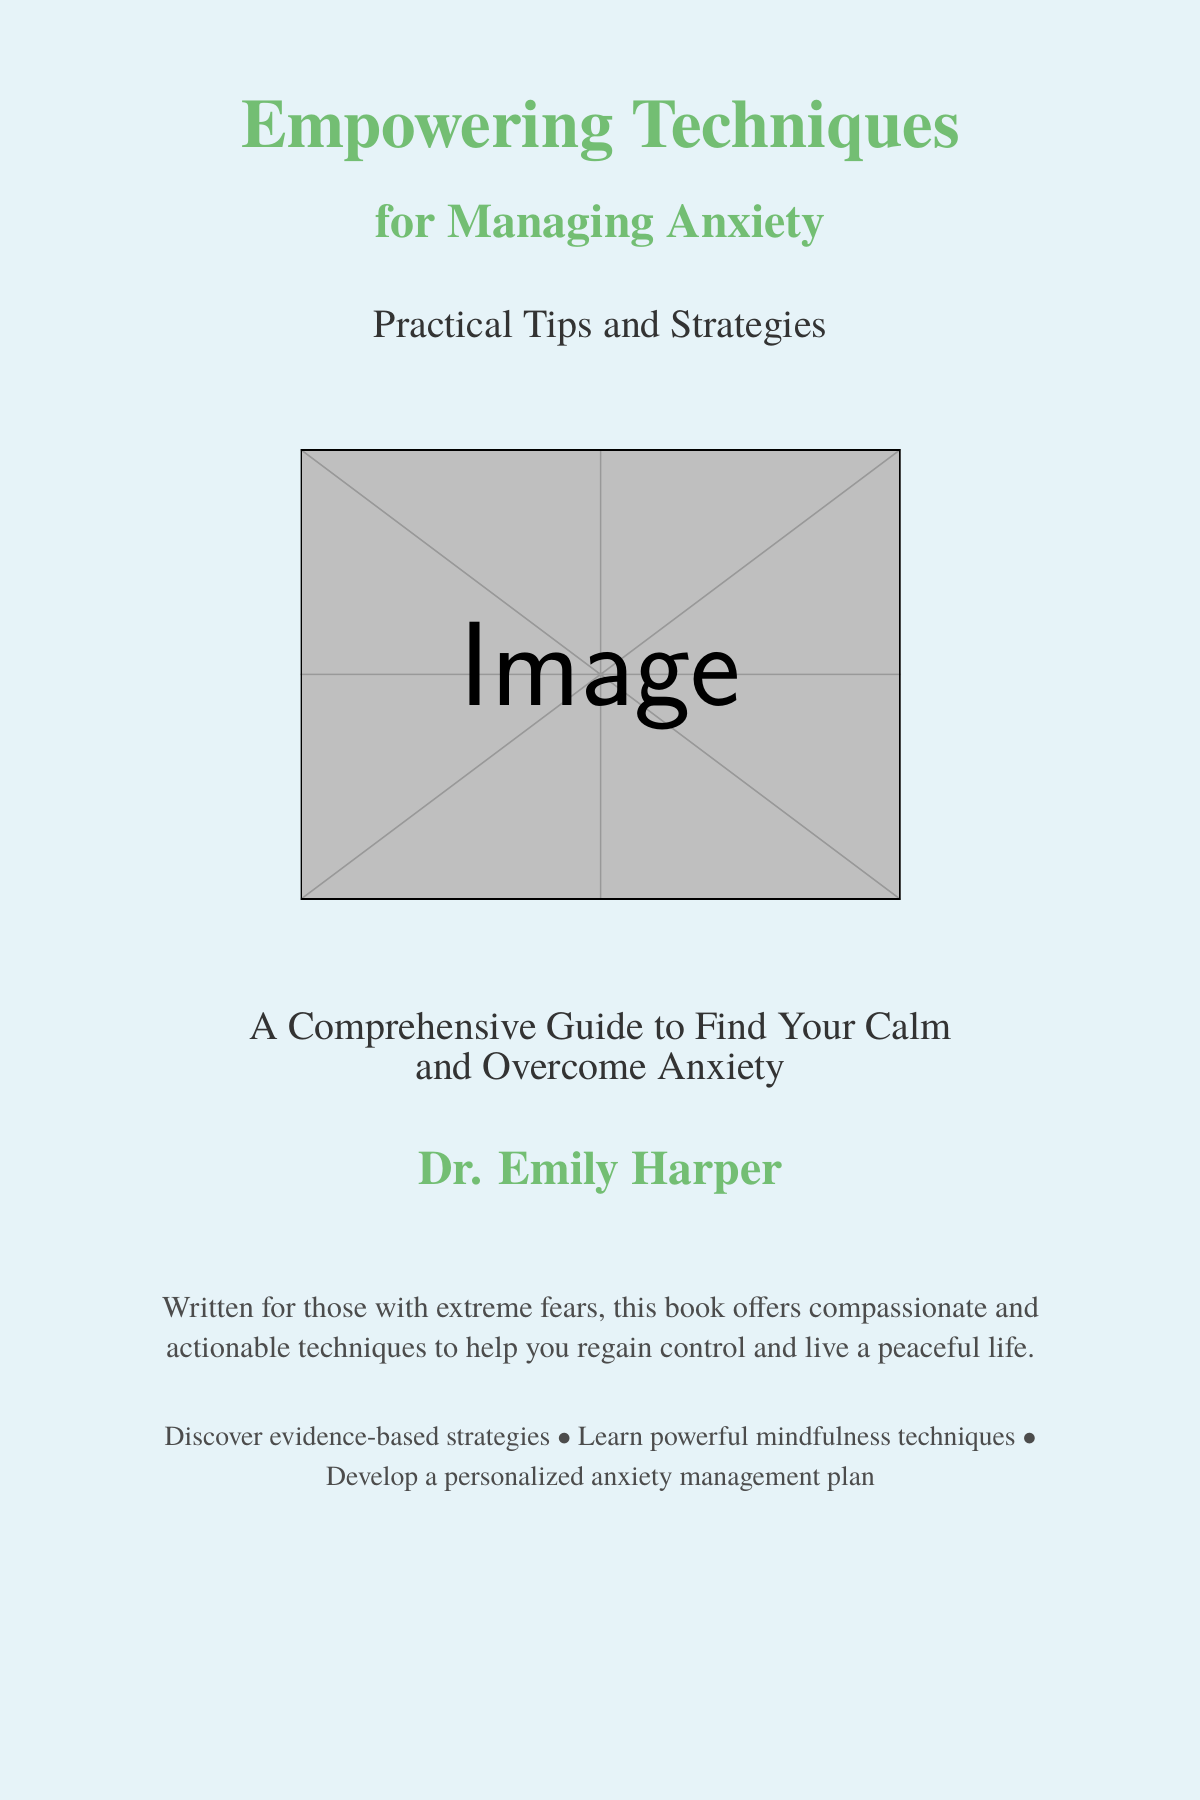what is the title of the book? The title of the book is prominently displayed at the top of the cover.
Answer: Empowering Techniques for Managing Anxiety who is the author of the book? The author's name is mentioned towards the bottom of the cover.
Answer: Dr. Emily Harper what type of strategies are included in the book? The book cover mentions the kind of content that can be discovered within it.
Answer: Practical Tips and Strategies what is the background color of the book cover? The background color is described in the document as calming.
Answer: Calm blue how does the cover describe the audience for the book? The cover states that it is written specifically for certain individuals.
Answer: Those with extreme fears what visual element is included on the cover? A visual representation is used to convey the message of calmness on the cover.
Answer: Mindfulness practice what is the main purpose of the book according to the cover? The cover summarizes the intent of the book in a few words.
Answer: Help you regain control what format is this document presented in? The structure and format are typical for books conveying content.
Answer: Book cover how does the cover indicate the nature of the techniques offered in the book? The techniques are described as compassionate and actionable.
Answer: Compassionate and actionable 